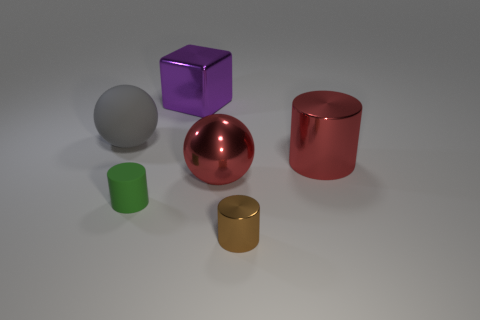Subtract all red cylinders. Subtract all brown cubes. How many cylinders are left? 2 Add 4 brown metallic cylinders. How many objects exist? 10 Subtract all balls. How many objects are left? 4 Subtract 0 gray cubes. How many objects are left? 6 Subtract all gray matte spheres. Subtract all big rubber things. How many objects are left? 4 Add 1 small green matte cylinders. How many small green matte cylinders are left? 2 Add 4 large cyan matte things. How many large cyan matte things exist? 4 